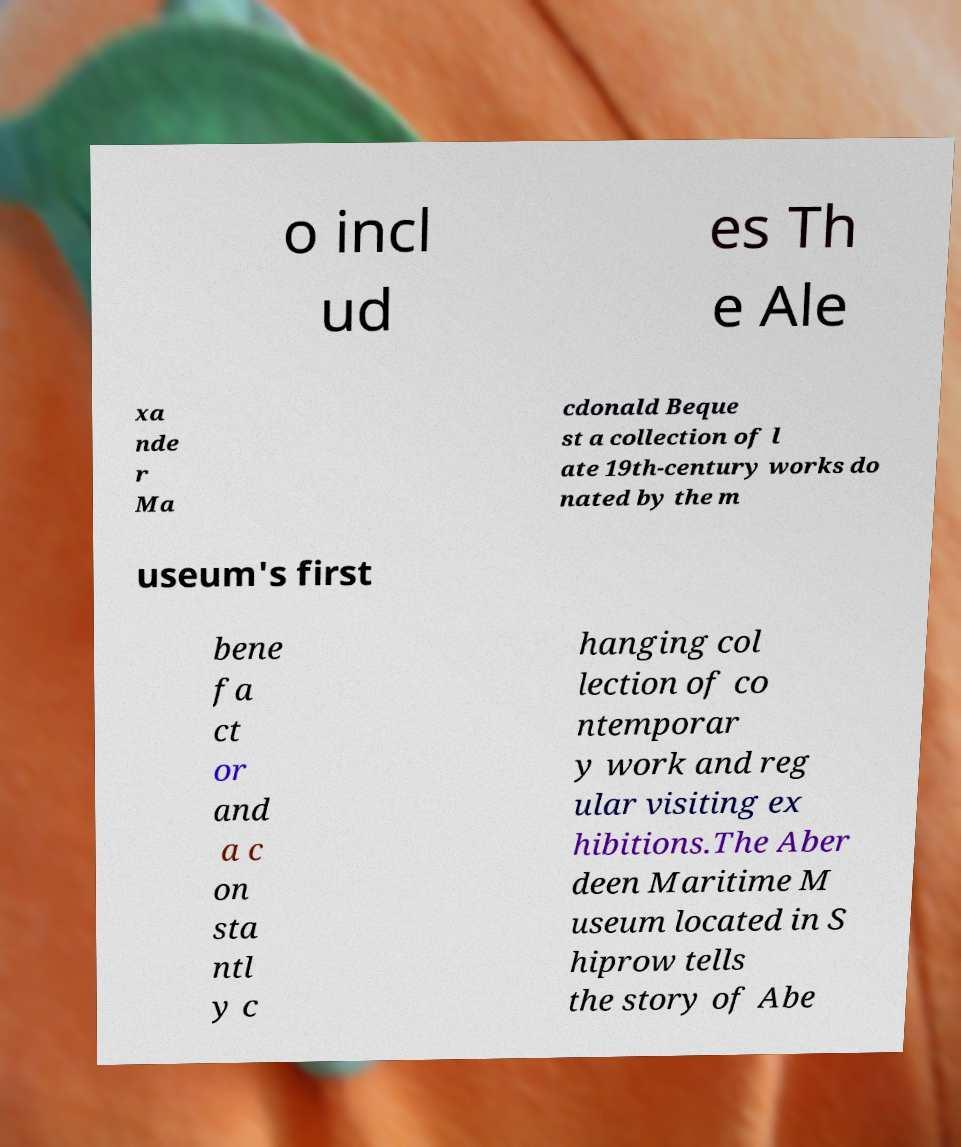I need the written content from this picture converted into text. Can you do that? o incl ud es Th e Ale xa nde r Ma cdonald Beque st a collection of l ate 19th-century works do nated by the m useum's first bene fa ct or and a c on sta ntl y c hanging col lection of co ntemporar y work and reg ular visiting ex hibitions.The Aber deen Maritime M useum located in S hiprow tells the story of Abe 